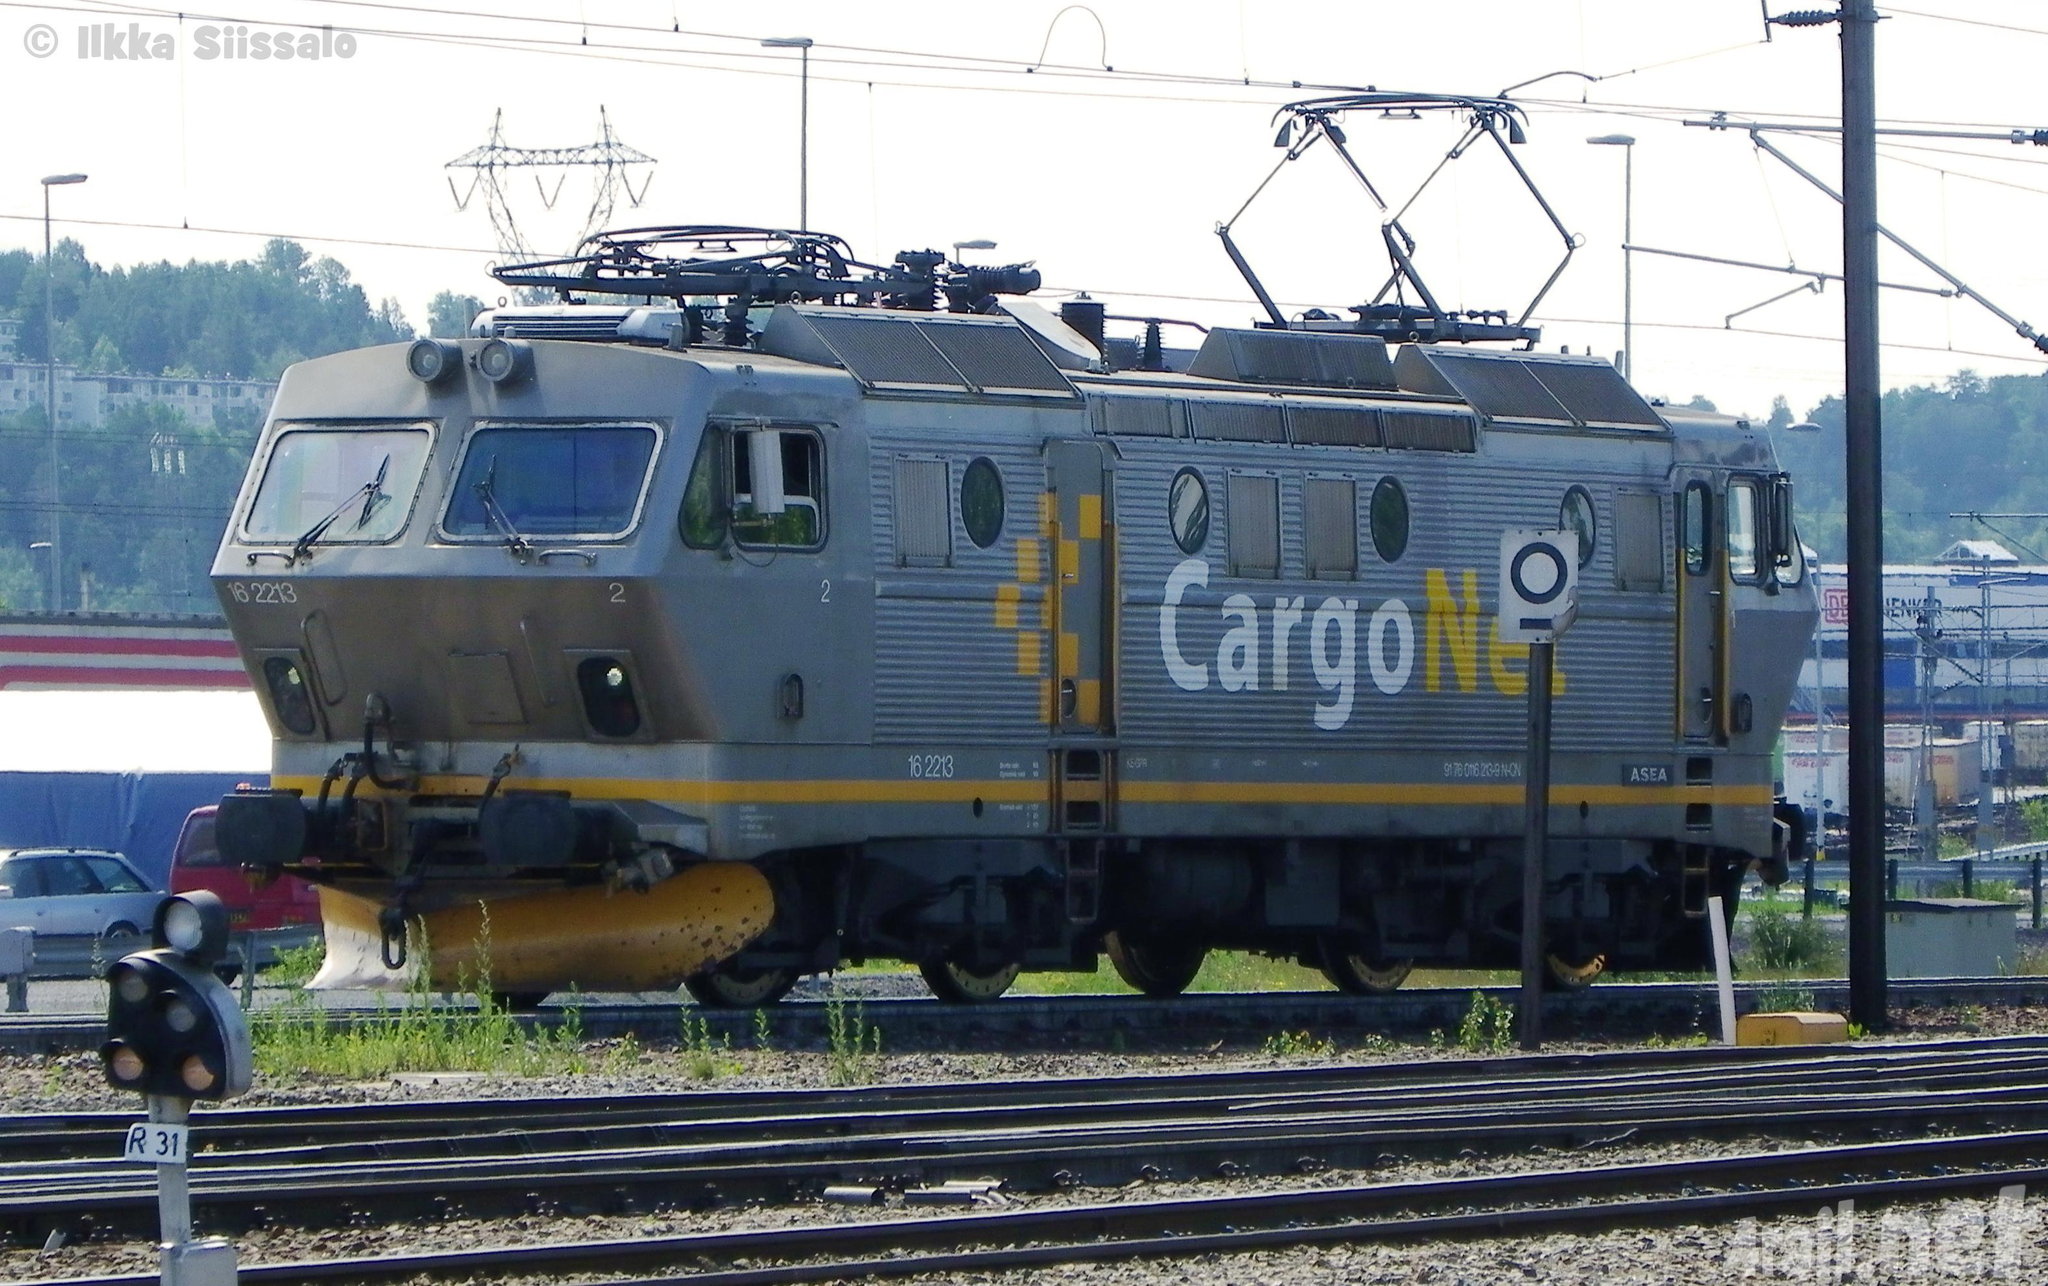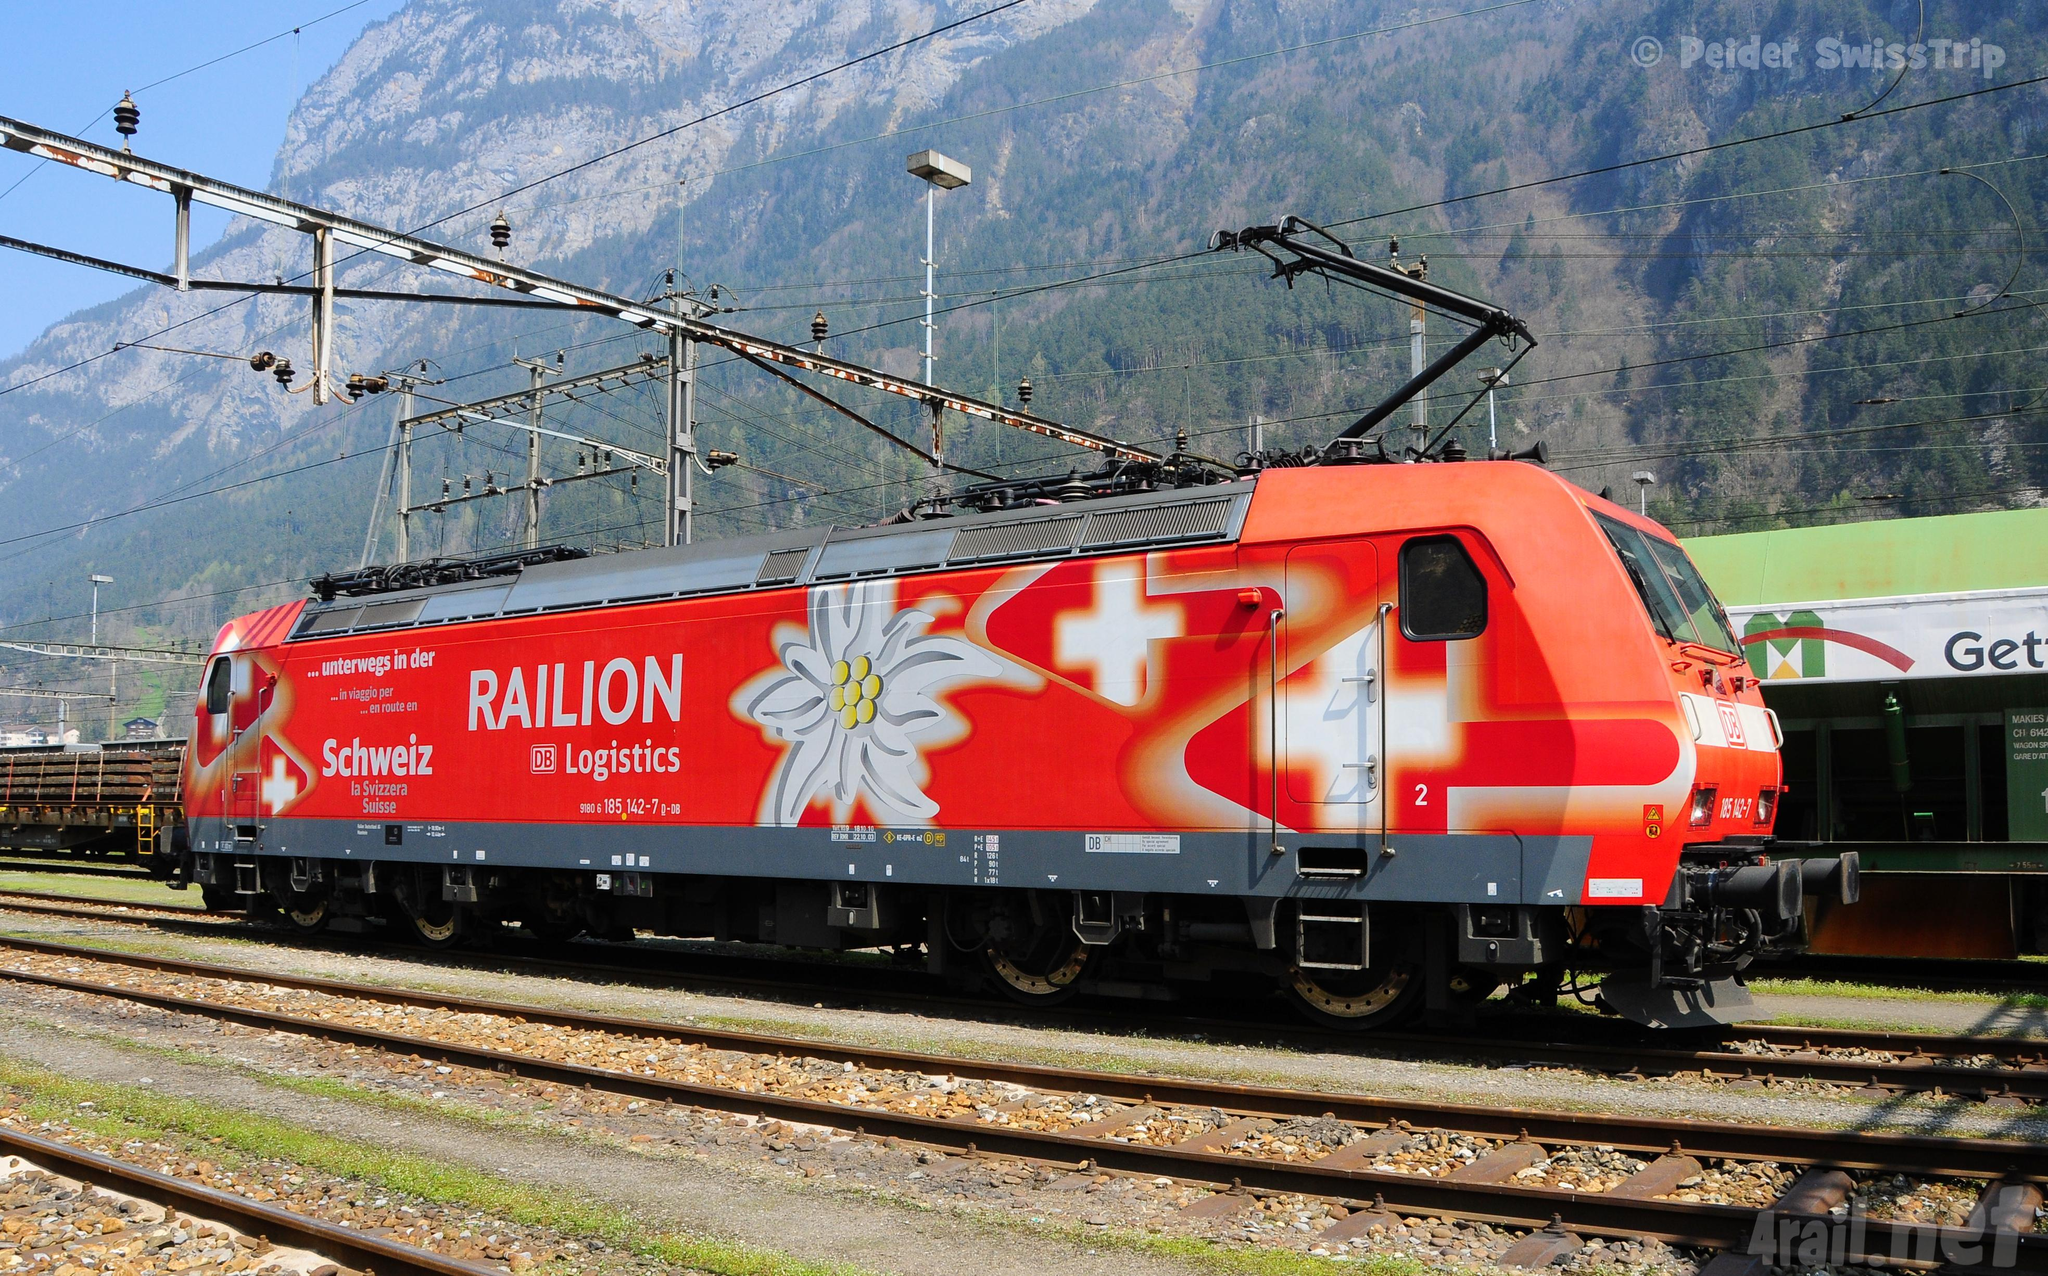The first image is the image on the left, the second image is the image on the right. For the images displayed, is the sentence "There are at least four train cars in the image on the right." factually correct? Answer yes or no. No. 